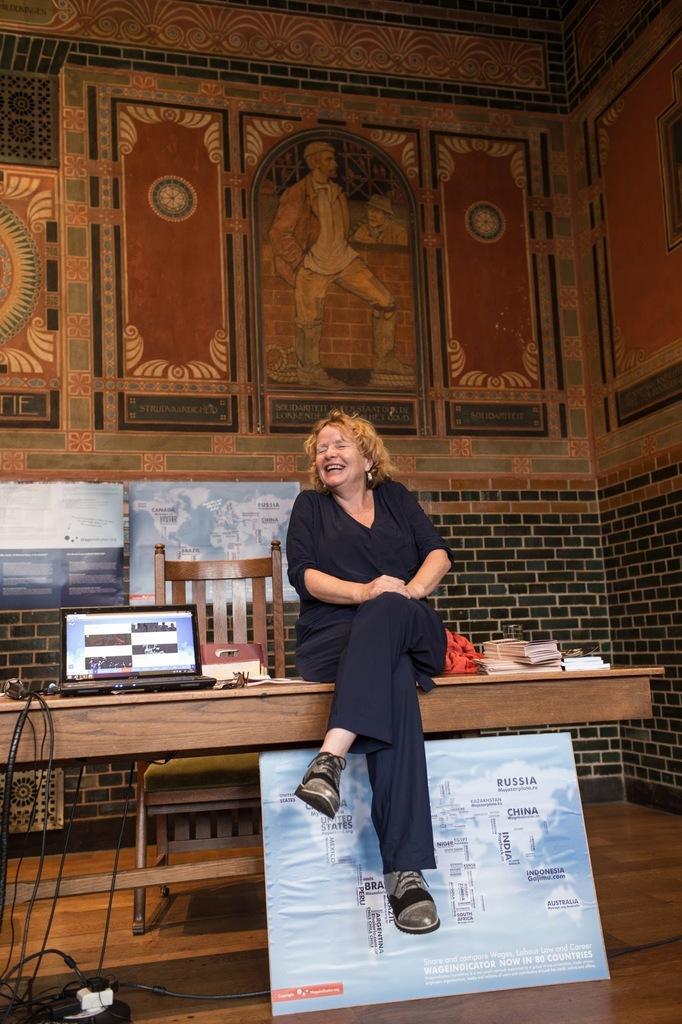In one or two sentences, can you explain what this image depicts? In this picture we observe a lady sitting on a wooden table and there is a photograph beneath it and there are two photographs fitted to the wall and in the background we observe a decorated wall. 